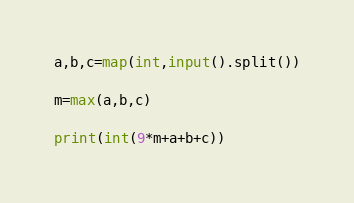Convert code to text. <code><loc_0><loc_0><loc_500><loc_500><_Python_>a,b,c=map(int,input().split())

m=max(a,b,c)

print(int(9*m+a+b+c))</code> 